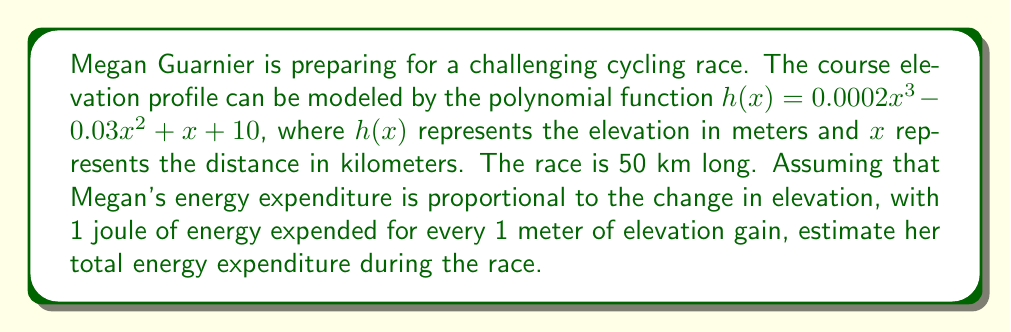Teach me how to tackle this problem. To solve this problem, we need to follow these steps:

1) First, we need to find the total elevation gain throughout the race. This can be done by calculating the derivative of the elevation function and integrating its positive parts.

2) The derivative of $h(x)$ is:
   $$h'(x) = 0.0006x^2 - 0.06x + 1$$

3) To find where $h'(x)$ is positive (uphill sections), we need to solve:
   $$0.0006x^2 - 0.06x + 1 > 0$$

4) This quadratic inequality can be solved by finding its roots:
   $$x = \frac{0.06 \pm \sqrt{0.06^2 - 4(0.0006)(1)}}{2(0.0006)}$$
   $$x \approx 8.45 \text{ or } x \approx 91.55$$

5) Since the race is only 50 km long, $h'(x)$ is positive for $0 \leq x < 8.45$ and $x > 91.55$ (which is beyond the race distance).

6) Now we can integrate the positive part of $h'(x)$ from 0 to 8.45:
   $$\int_0^{8.45} (0.0006x^2 - 0.06x + 1) dx$$
   $$= [0.0002x^3 - 0.03x^2 + x]_0^{8.45}$$
   $$\approx 4.22 \text{ meters}$$

7) For the remainder of the race (8.45 km to 50 km), the elevation is decreasing, so we don't add to the energy expenditure.

8) Therefore, the total elevation gain is approximately 4.22 meters.

9) Since 1 joule is expended for every 1 meter of elevation gain, the total energy expenditure is approximately 4.22 joules.
Answer: Megan Guarnier's estimated energy expenditure during the race is approximately 4.22 joules. 